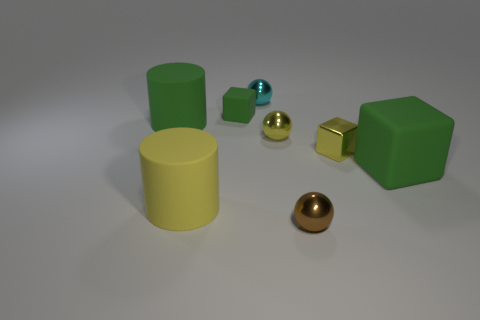Subtract all blue spheres. Subtract all blue cylinders. How many spheres are left? 3 Add 2 tiny yellow balls. How many objects exist? 10 Subtract all balls. How many objects are left? 5 Subtract 0 red cubes. How many objects are left? 8 Subtract all yellow metal spheres. Subtract all yellow shiny balls. How many objects are left? 6 Add 3 yellow shiny balls. How many yellow shiny balls are left? 4 Add 5 brown spheres. How many brown spheres exist? 6 